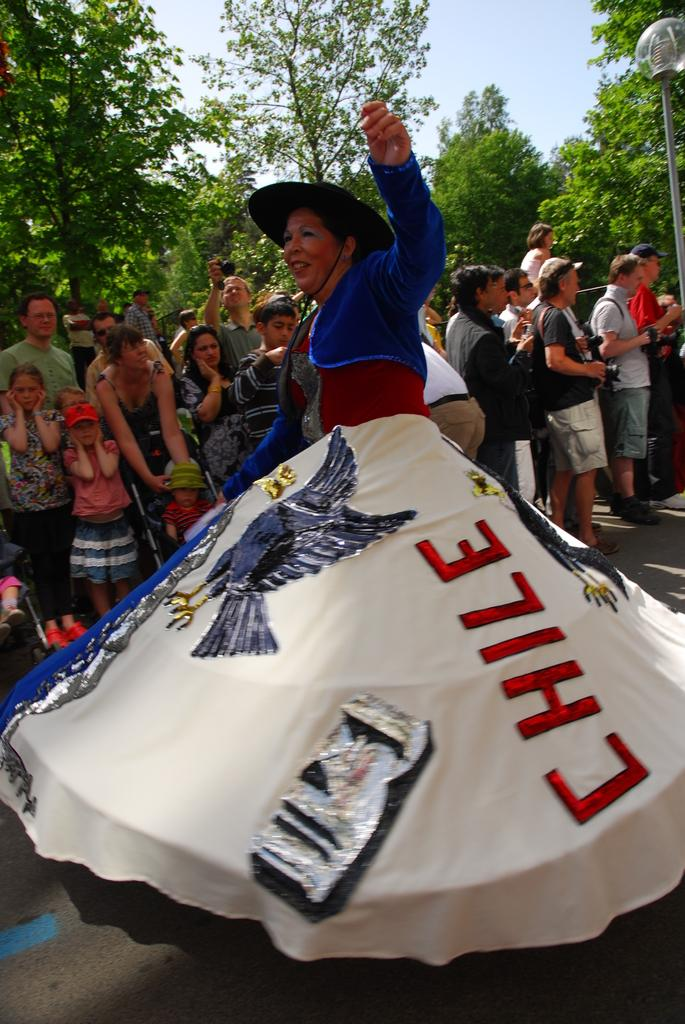What is the main subject of the image? The main subject of the image is a woman. What is the woman doing in the image? The woman is performing an activity. How is the woman dressed in the image? The woman is wearing a different costume. Can you describe the environment around the woman? There is a huge crowd behind the woman, and there are many trees in the background of the image. What type of fang can be seen on the woman's costume in the image? There is no fang present on the woman's costume in the image. 